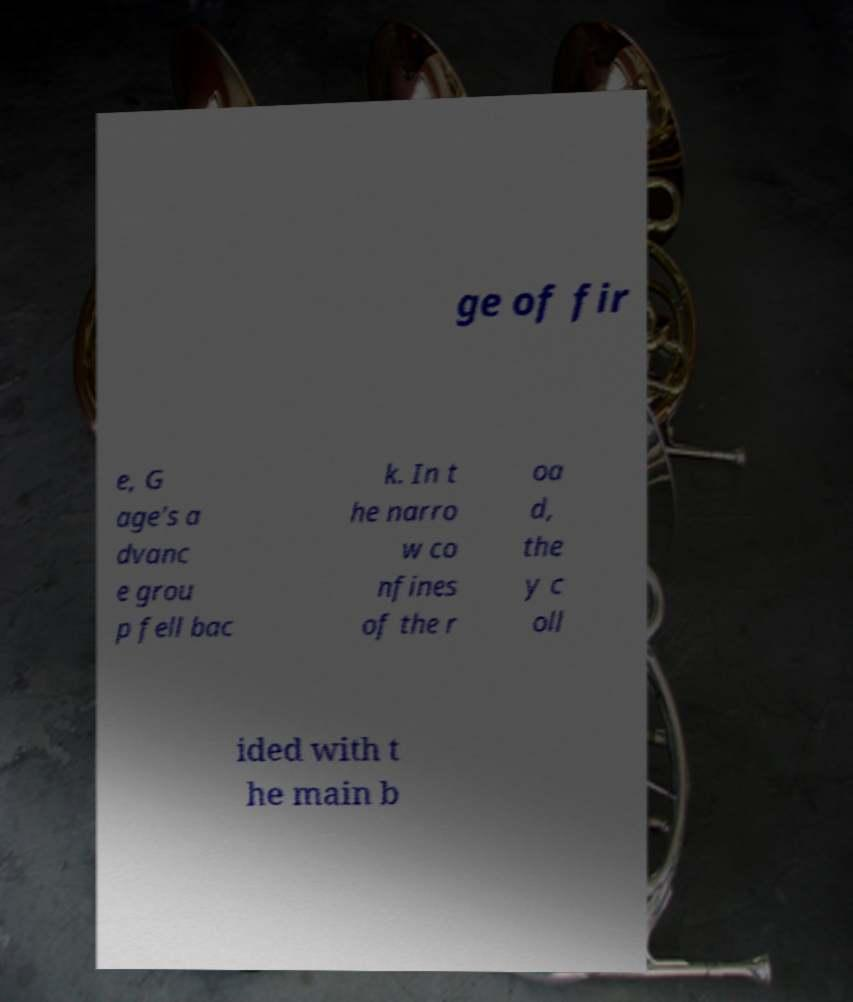I need the written content from this picture converted into text. Can you do that? ge of fir e, G age's a dvanc e grou p fell bac k. In t he narro w co nfines of the r oa d, the y c oll ided with t he main b 